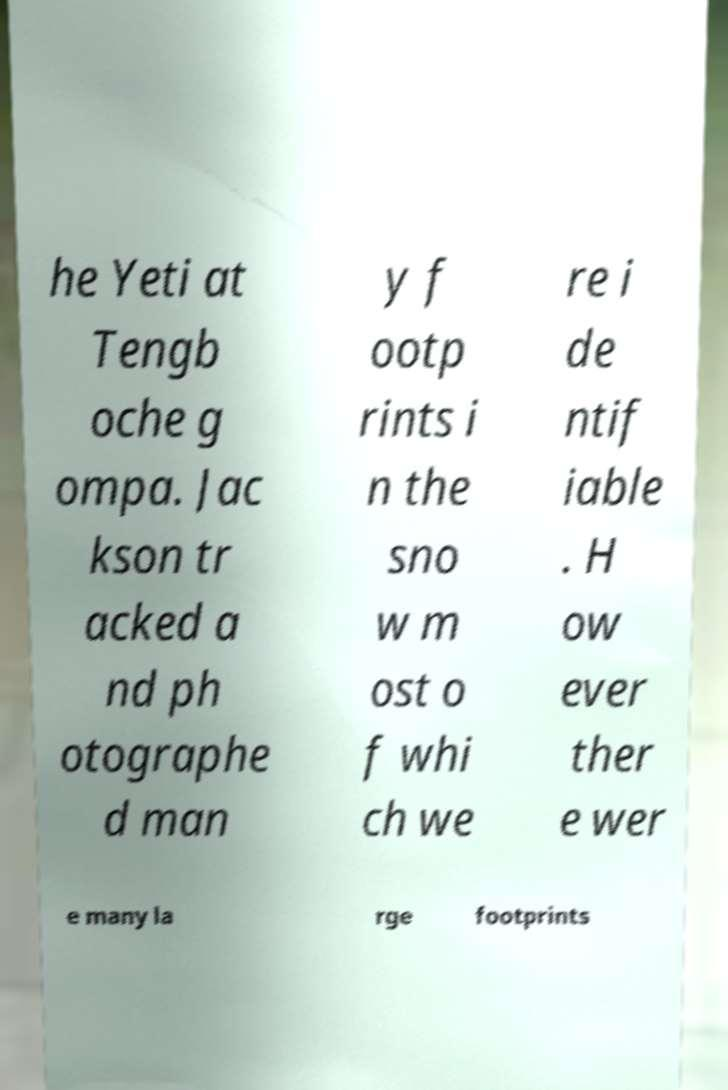Please read and relay the text visible in this image. What does it say? he Yeti at Tengb oche g ompa. Jac kson tr acked a nd ph otographe d man y f ootp rints i n the sno w m ost o f whi ch we re i de ntif iable . H ow ever ther e wer e many la rge footprints 